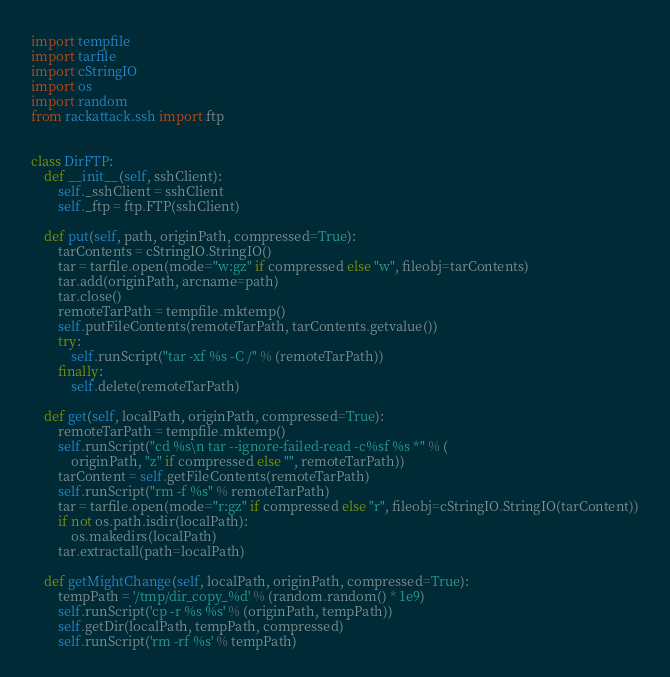<code> <loc_0><loc_0><loc_500><loc_500><_Python_>import tempfile
import tarfile
import cStringIO
import os
import random
from rackattack.ssh import ftp


class DirFTP:
    def __init__(self, sshClient):
        self._sshClient = sshClient
        self._ftp = ftp.FTP(sshClient)

    def put(self, path, originPath, compressed=True):
        tarContents = cStringIO.StringIO()
        tar = tarfile.open(mode="w:gz" if compressed else "w", fileobj=tarContents)
        tar.add(originPath, arcname=path)
        tar.close()
        remoteTarPath = tempfile.mktemp()
        self.putFileContents(remoteTarPath, tarContents.getvalue())
        try:
            self.runScript("tar -xf %s -C /" % (remoteTarPath))
        finally:
            self.delete(remoteTarPath)

    def get(self, localPath, originPath, compressed=True):
        remoteTarPath = tempfile.mktemp()
        self.runScript("cd %s\n tar --ignore-failed-read -c%sf %s *" % (
            originPath, "z" if compressed else "", remoteTarPath))
        tarContent = self.getFileContents(remoteTarPath)
        self.runScript("rm -f %s" % remoteTarPath)
        tar = tarfile.open(mode="r:gz" if compressed else "r", fileobj=cStringIO.StringIO(tarContent))
        if not os.path.isdir(localPath):
            os.makedirs(localPath)
        tar.extractall(path=localPath)

    def getMightChange(self, localPath, originPath, compressed=True):
        tempPath = '/tmp/dir_copy_%d' % (random.random() * 1e9)
        self.runScript('cp -r %s %s' % (originPath, tempPath))
        self.getDir(localPath, tempPath, compressed)
        self.runScript('rm -rf %s' % tempPath)
</code> 